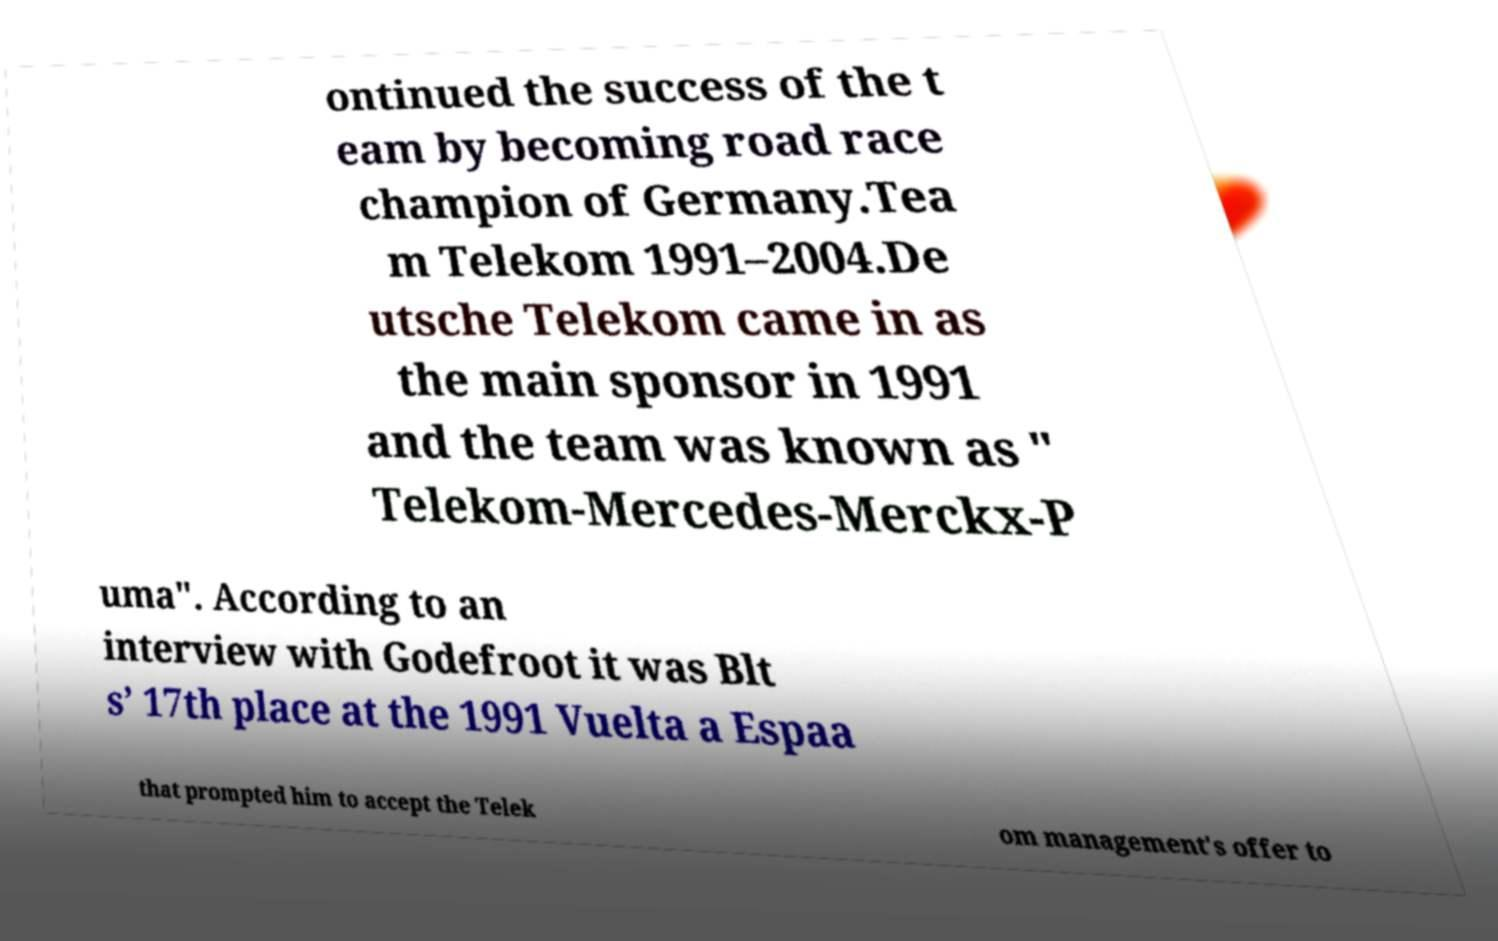For documentation purposes, I need the text within this image transcribed. Could you provide that? ontinued the success of the t eam by becoming road race champion of Germany.Tea m Telekom 1991–2004.De utsche Telekom came in as the main sponsor in 1991 and the team was known as " Telekom-Mercedes-Merckx-P uma". According to an interview with Godefroot it was Blt s’ 17th place at the 1991 Vuelta a Espaa that prompted him to accept the Telek om management's offer to 